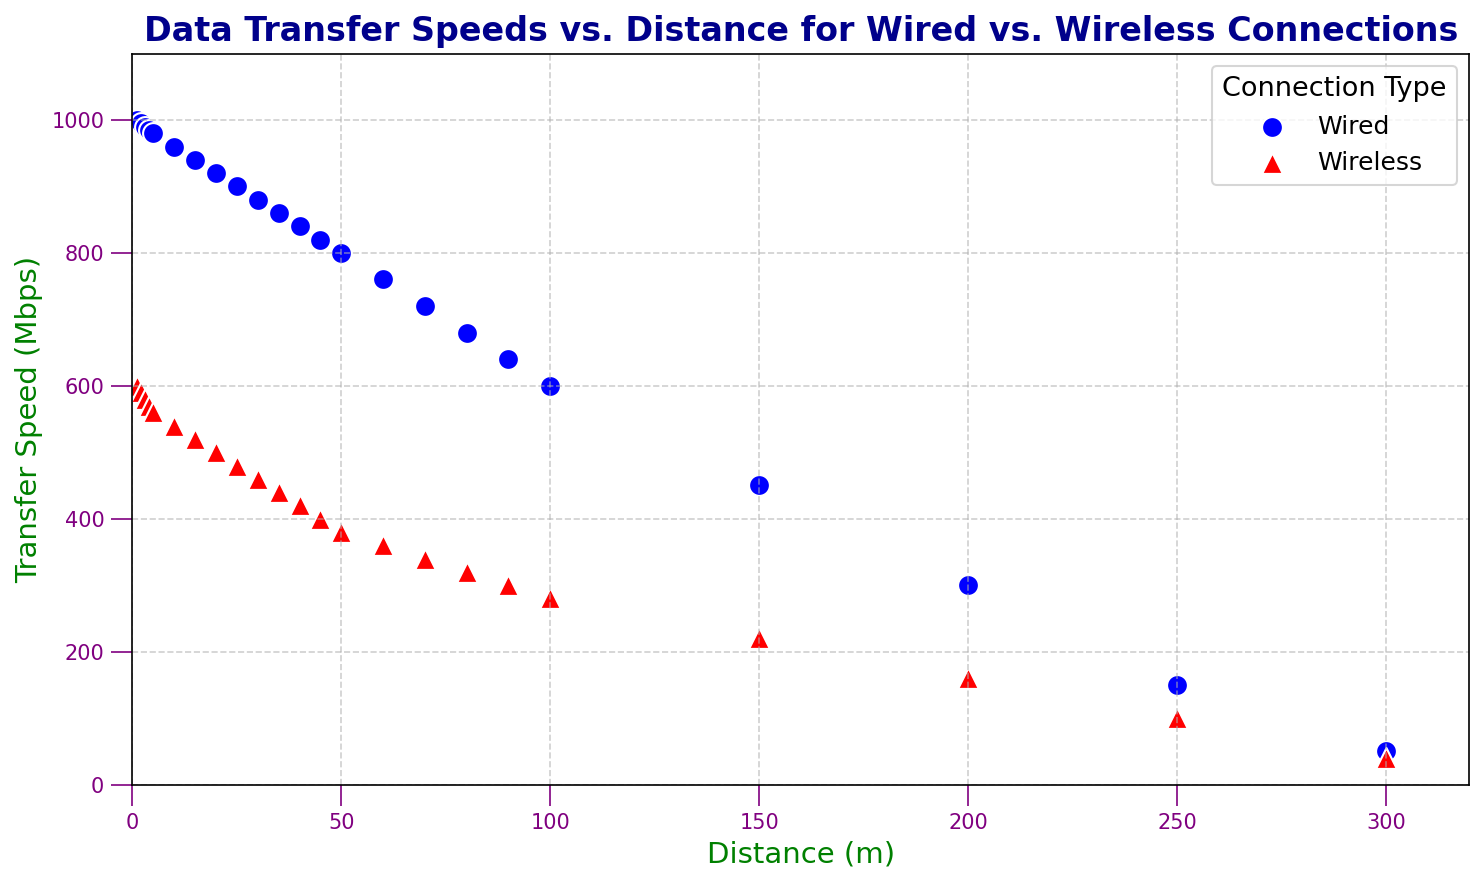What's the general trend of data transfer speeds as distance increases for both connection types? By observing the scatter plot, we notice that both wired and wireless data transfer speeds decrease as the distance increases. This is evident from the downward pattern of data points for both connection types.
Answer: Decreasing At a distance of 50 meters, which connection type has a higher data transfer speed and by how much? At 50 meters, the wired connection data transfer speed is represented by a blue circle, and the wireless connection is represented by a red triangle. The wired speed is 800 Mbps, and the wireless speed is 380 Mbps. By subtracting 380 from 800, we find the wired connection is higher by 420 Mbps.
Answer: Wired, by 420 Mbps Which connection type maintains higher transfer speeds over longer distances, and what feature on the plot suggests this? The scatter plot demonstrates that wired connections, represented by blue circles, generally maintain higher transfer speeds at longer distances compared to wireless connections, represented by red triangles. The blue circles consistently have higher y-values (transfer speed) than the red triangles for distances beyond 50 meters.
Answer: Wired, blue circles higher than red triangles What is the transfer speed difference between wired and wireless connections at a distance of 200 meters? By locating the points for both type of connections at 200 meters on the x-axis, the wired speed is 300 Mbps, and the wireless speed is 160 Mbps. The difference is 300 - 160 equals 140 Mbps.
Answer: 140 Mbps At which distance do the wired and wireless connections first drop below a transfer speed of 500 Mbps? Observing the scatter plot, the wired connection data points first drop below 500 Mbps at a distance of 150 meters. Wireless connections drop below 500 Mbps at 20 meters.
Answer: Wired: 150 meters, Wireless: 20 meters Is there any distance range where both wired and wireless connections maintain transfer speeds above 800 Mbps? Inspecting the scatter plot, both wired and wireless connections maintain transfer speeds above 800 Mbps only between 1 and 5 meters, as indicated by both sets of points being above the 800 Mbps line within that range.
Answer: 1 to 5 meters At a distance of 10 meters, what is the combined transfer speed for both connection types? The transfer speed for wired connections at 10 meters is 960 Mbps, and for wireless connections, it is 540 Mbps. The combined transfer speed is the sum of these values: 960 + 540 = 1500 Mbps.
Answer: 1500 Mbps How does the variation in transfer speeds compare between wired and wireless connections beyond 100 meters? Beyond 100 meters, wired connections (blue circles) show a slower degradation in transfer speed compared to wireless connections (red triangles). This is illustrated by the steeper drop in red triangle positions on the graph relative to the blue circles.
Answer: Wired degrades slower than wireless 